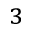Convert formula to latex. <formula><loc_0><loc_0><loc_500><loc_500>^ { 3 }</formula> 